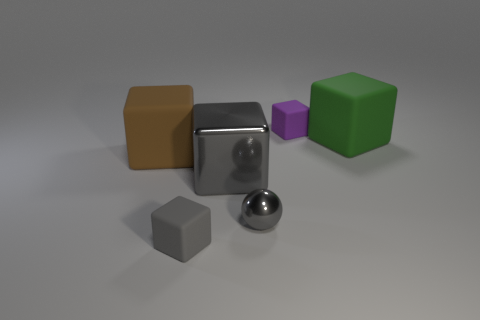What is the size of the rubber thing that is the same color as the small sphere?
Make the answer very short. Small. What shape is the big metallic thing that is the same color as the ball?
Your answer should be very brief. Cube. There is a gray metal thing left of the small metallic ball; what size is it?
Ensure brevity in your answer.  Large. Do the shiny cube and the tiny rubber object that is on the right side of the tiny shiny object have the same color?
Provide a succinct answer. No. What number of other things are the same material as the big brown thing?
Keep it short and to the point. 3. Is the number of large gray metallic objects greater than the number of small cyan shiny objects?
Provide a succinct answer. Yes. Does the small matte cube left of the tiny purple block have the same color as the large metal cube?
Provide a short and direct response. Yes. The large metal thing is what color?
Your answer should be very brief. Gray. Is there a small object behind the big rubber block that is right of the purple thing?
Give a very brief answer. Yes. What shape is the tiny gray object on the right side of the small block in front of the large metal thing?
Provide a succinct answer. Sphere. 